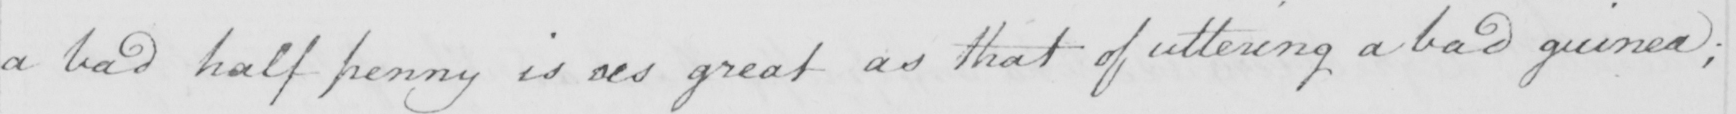What is written in this line of handwriting? a bad half penny is as great as that of uttering a bad guinea ; 